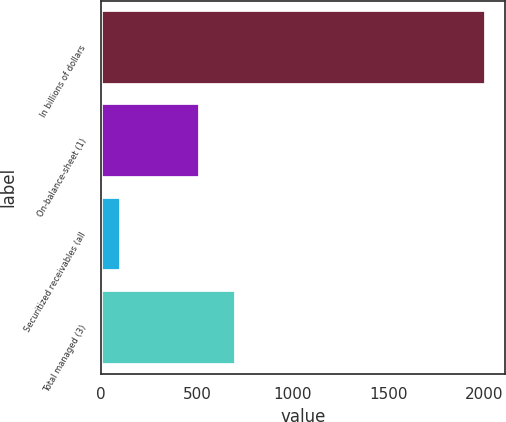Convert chart. <chart><loc_0><loc_0><loc_500><loc_500><bar_chart><fcel>In billions of dollars<fcel>On-balance-sheet (1)<fcel>Securitized receivables (all<fcel>Total managed (3)<nl><fcel>2008<fcel>515.7<fcel>105.9<fcel>705.91<nl></chart> 